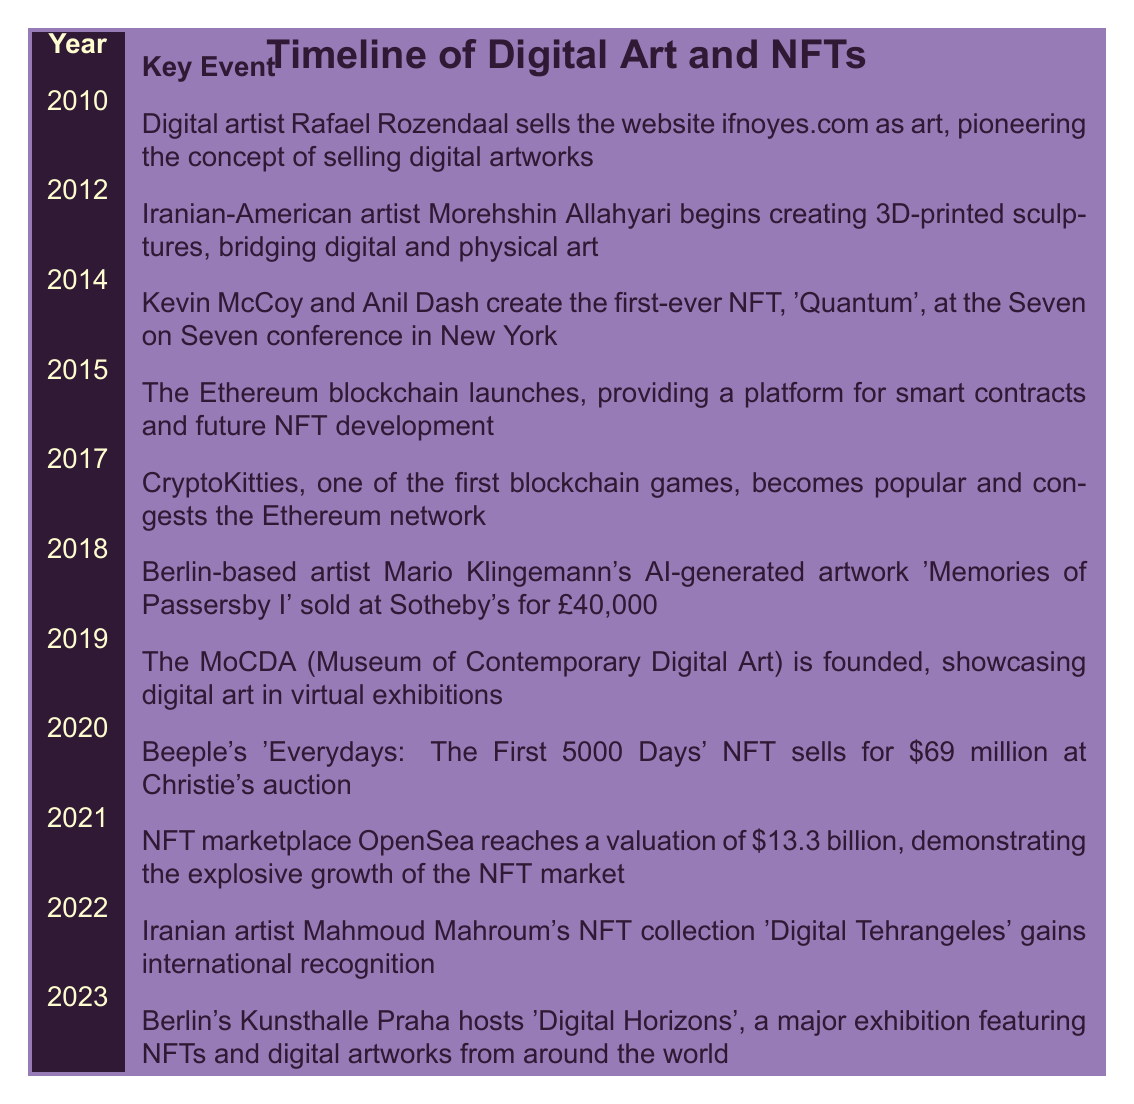What year did Kevin McCoy and Anil Dash create the first-ever NFT? The table lists the event of the first-ever NFT creation by Kevin McCoy and Anil Dash in the year 2014.
Answer: 2014 Which artist's digital artwork sold for £40,000 at Sotheby's in 2018? According to the table, the artist Mario Klingemann's AI-generated artwork 'Memories of Passersby I' sold for this amount at Sotheby's in 2018.
Answer: Mario Klingemann True or false: The Ethereum blockchain launched in 2015. The table clearly states that the Ethereum blockchain launched in 2015, making the statement true.
Answer: True What was the valuation of the NFT marketplace OpenSea in 2021? The table indicates that OpenSea reached a valuation of $13.3 billion in 2021.
Answer: $13.3 billion How many years passed between the launch of the Ethereum blockchain and Beeple's NFT sale? The Ethereum blockchain launched in 2015 and Beeple's NFT sold in 2020, which is 5 years apart as 2020 - 2015 = 5.
Answer: 5 years What significant digital art event happened in 2010? According to the table, the event in 2010 involved Rafael Rozendaal selling the website ifnoyes.com as art, which pioneered the concept of selling digital artworks.
Answer: Rafael Rozendaal sells ifnoyes.com True or false: The MoCDA (Museum of Contemporary Digital Art) was founded before 2020. The table shows that the MoCDA was founded in 2019, which is before 2020, making this statement true.
Answer: True Which event had the highest monetary value, and how much was it? The table states that Beeple's NFT 'Everydays: The First 5000 Days' sold for $69 million in 2020, which is the highest monetary value presented in these events.
Answer: $69 million How does the event in 2022 relate to Iranian artists? The table states that in 2022, Iranian artist Mahmoud Mahroum's NFT collection 'Digital Tehrangeles' gained international recognition, indicating a significant accomplishment for Iranian artists in the digital art space.
Answer: Mahmoud Mahroum's NFT collection gains recognition 